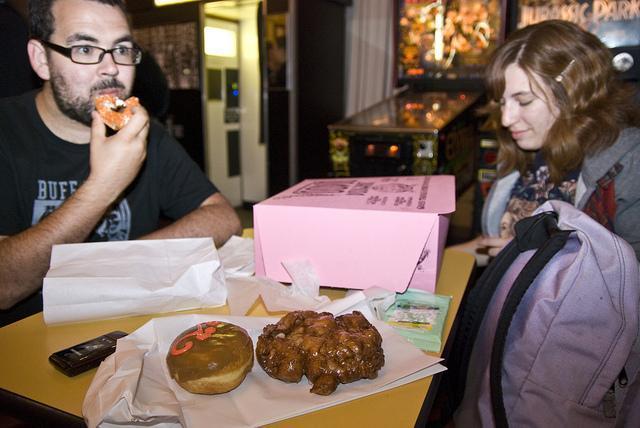How many people can you see?
Give a very brief answer. 2. 